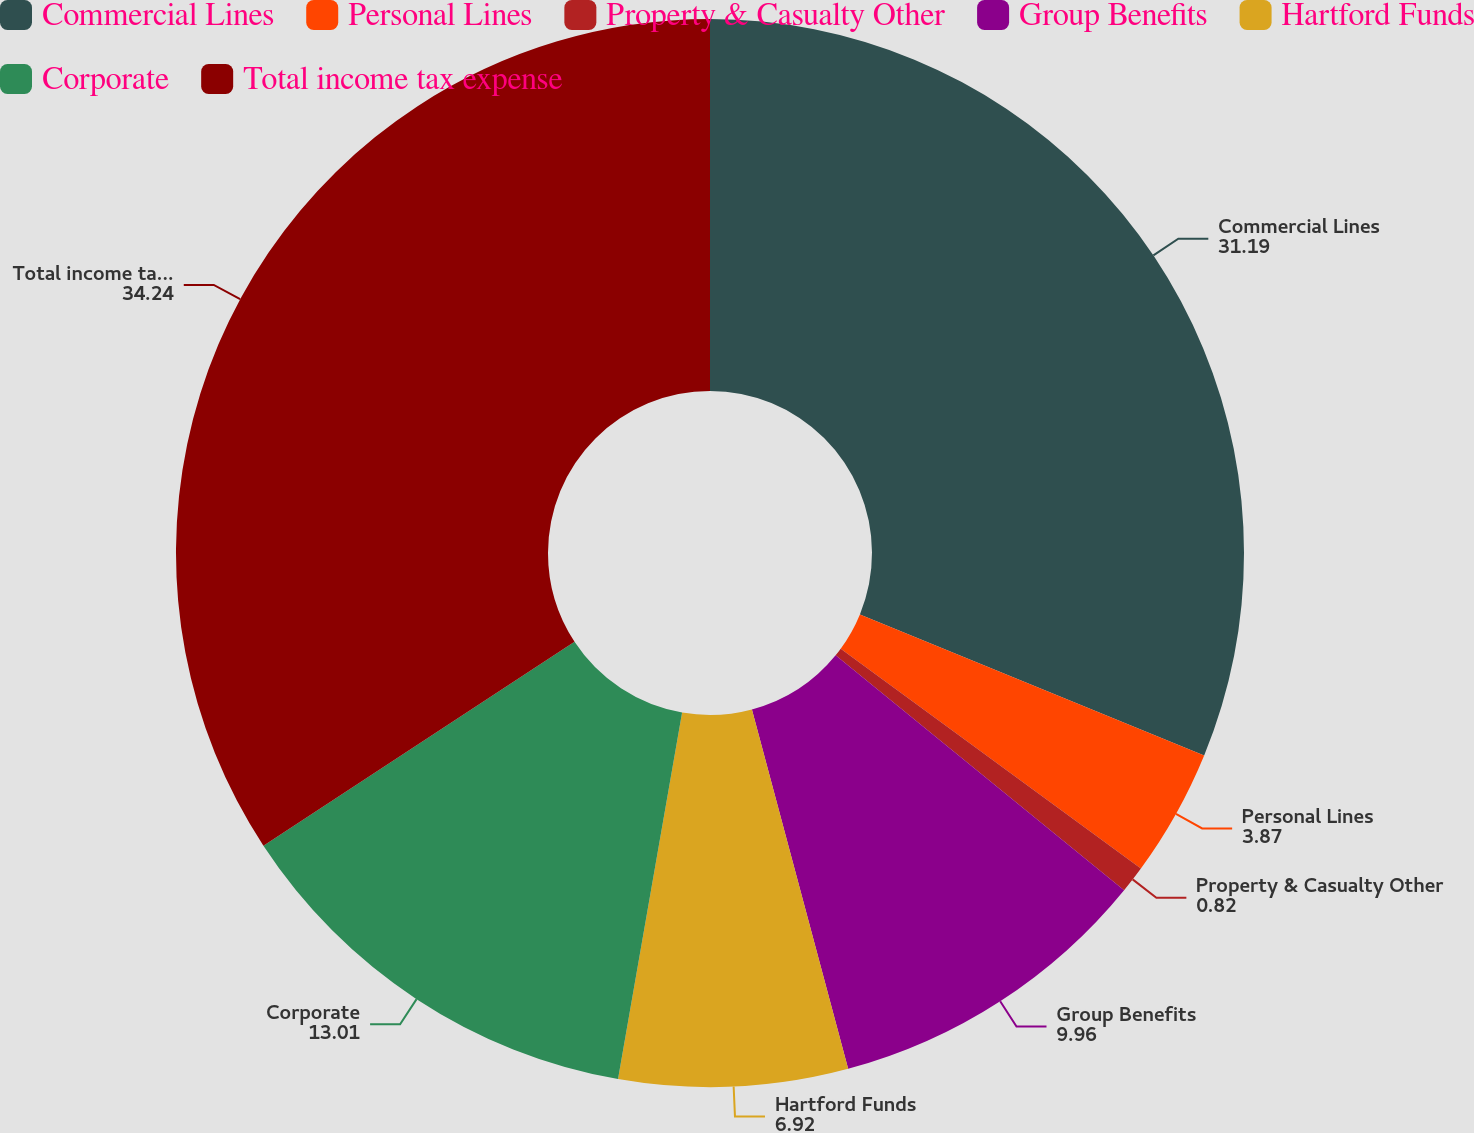Convert chart to OTSL. <chart><loc_0><loc_0><loc_500><loc_500><pie_chart><fcel>Commercial Lines<fcel>Personal Lines<fcel>Property & Casualty Other<fcel>Group Benefits<fcel>Hartford Funds<fcel>Corporate<fcel>Total income tax expense<nl><fcel>31.19%<fcel>3.87%<fcel>0.82%<fcel>9.96%<fcel>6.92%<fcel>13.01%<fcel>34.24%<nl></chart> 